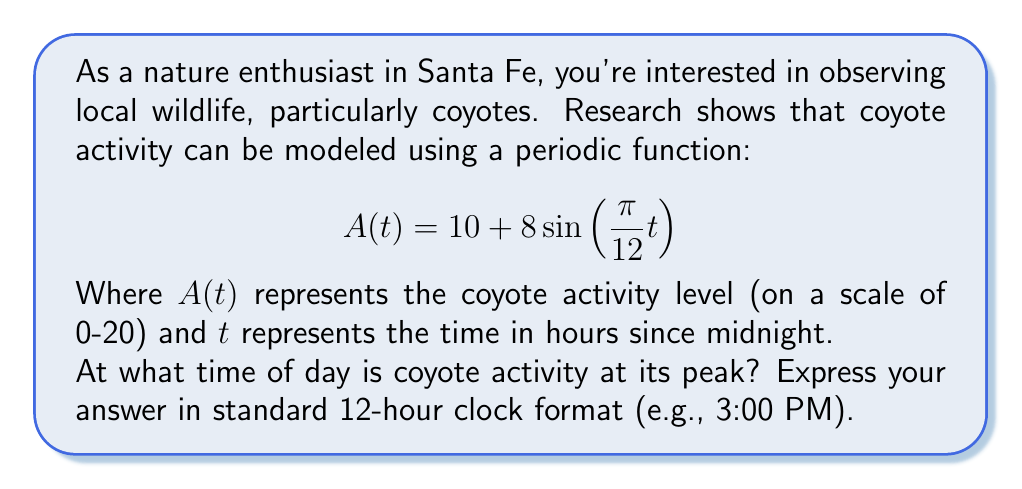Teach me how to tackle this problem. To find the peak activity time, we need to determine when the function $A(t)$ reaches its maximum value. For a sine function, this occurs when the argument of sine equals $\frac{\pi}{2}$ (or 90 degrees).

1) Set up the equation:
   $\frac{\pi}{12}t = \frac{\pi}{2}$

2) Solve for $t$:
   $t = \frac{\pi}{2} \cdot \frac{12}{\pi} = 6$

3) This means the peak occurs 6 hours after midnight, which is 6:00 AM.

To verify:
- At $t=6$, $A(6) = 10 + 8\sin(\frac{\pi}{12} \cdot 6) = 10 + 8\sin(\frac{\pi}{2}) = 10 + 8 = 18$
- This is indeed the maximum value of the function.

4) Convert to 12-hour clock format:
   6:00 AM is already in the correct format.

Note: The function will reach this peak every 24 hours, so there will be another peak at 6:00 PM. However, since the question asks for a single time, we typically provide the first occurrence after midnight.
Answer: 6:00 AM 